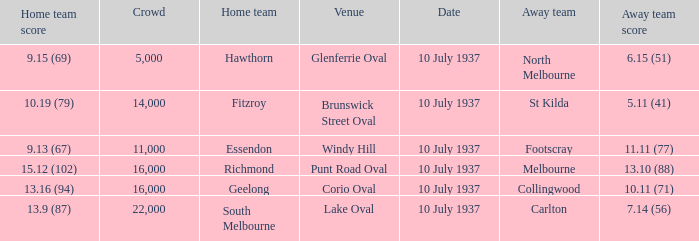What was the lowest Crowd during the Away Team Score of 10.11 (71)? 16000.0. 